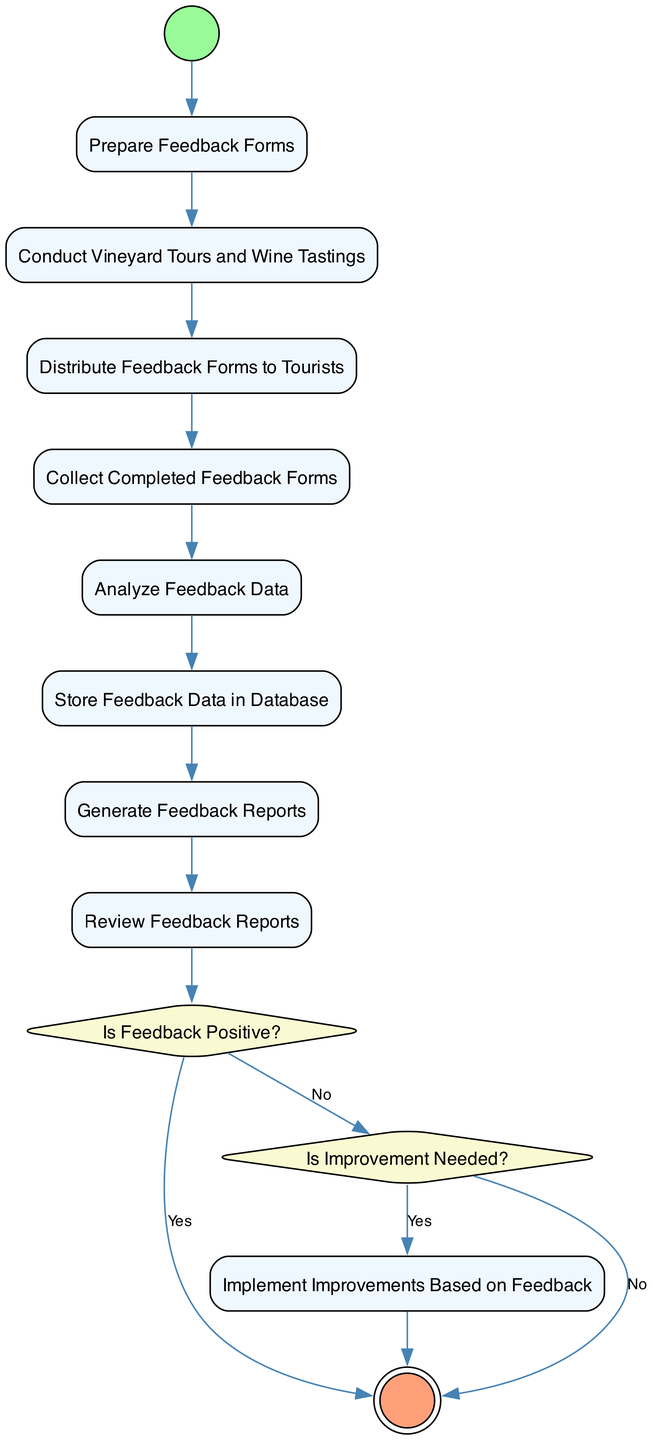What is the first activity in the diagram? The first activity, indicated by the initial node, is "Start Feedback Collection." It starts the entire process of collecting customer feedback.
Answer: Start Feedback Collection How many actions are involved in the feedback collection process? The feedback collection process involves eight action nodes: Prepare Feedback Forms, Conduct Vineyard Tours and Wine Tastings, Distribute Feedback Forms to Tourists, Collect Completed Feedback Forms, Analyze Feedback Data, Store Feedback Data in Database, Generate Feedback Reports, and Review Feedback Reports. Adding these gives a total of eight actions.
Answer: Eight What is the decision made after reviewing feedback reports? The decision made is "Is Feedback Positive?" This is a critical juncture that determines the next steps in the feedback collection process based on the feedback's positivity.
Answer: Is Feedback Positive? If the feedback is positive, what is the next activity? If the feedback is positive, the next activity is to end the feedback collection process, as it indicates no immediate improvements are needed based on the feedback received.
Answer: End Feedback Collection What happens if improvements are needed after analyzing the feedback data? If improvements are needed, the process flows to "Implement Improvements Based on Feedback", indicating that based on the feedback analysis, necessary changes will be made.
Answer: Implement Improvements Based on Feedback What are the final steps in the customer feedback collection process? The final steps are to review the feedback reports, make a decision about the feedback's positivity, and depending on that decision, either implement improvements or end the feedback collection process.
Answer: End Feedback Collection How many decisions are present in the diagram? There are two decisions illustrated in the diagram: "Is Feedback Positive?" and "Is Improvement Needed?" Each decision leads to different subsequent actions based on the feedback evaluation.
Answer: Two Which activities follow the "Analyze Feedback Data" node? After "Analyze Feedback Data", the activities are "Store Feedback Data in Database", "Generate Feedback Reports", and "Review Feedback Reports" sequentially. Each follows logically from the analysis to data storage and then reporting.
Answer: Store Feedback Data in Database What activity is reached if feedback is not positive? If the feedback is not positive, it leads to the decision node "Is Improvement Needed?", and if improvements are indeed needed, it further goes to "Implement Improvements Based on Feedback."
Answer: Implement Improvements Based on Feedback 